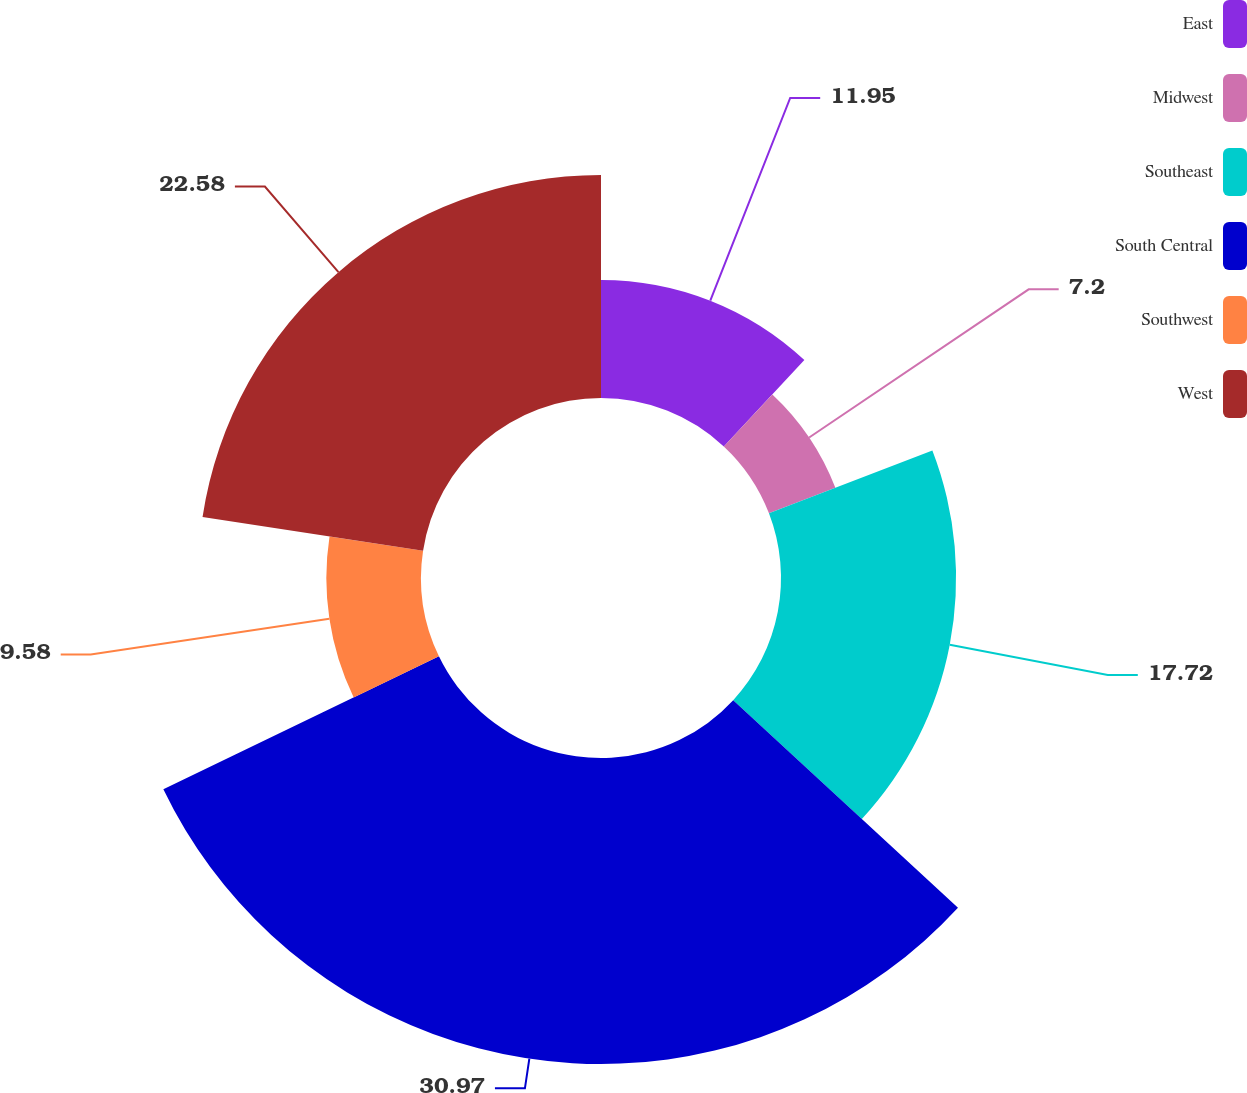<chart> <loc_0><loc_0><loc_500><loc_500><pie_chart><fcel>East<fcel>Midwest<fcel>Southeast<fcel>South Central<fcel>Southwest<fcel>West<nl><fcel>11.95%<fcel>7.2%<fcel>17.72%<fcel>30.97%<fcel>9.58%<fcel>22.58%<nl></chart> 